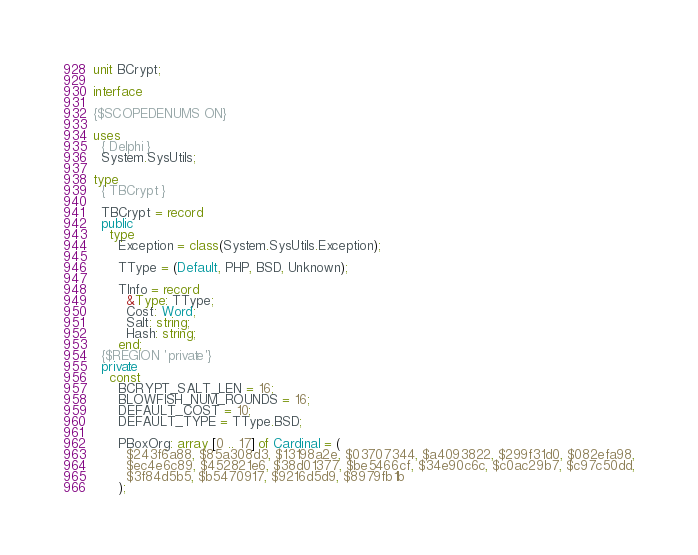<code> <loc_0><loc_0><loc_500><loc_500><_Pascal_>unit BCrypt;

interface

{$SCOPEDENUMS ON}

uses
  { Delphi }
  System.SysUtils;

type
  { TBCrypt }

  TBCrypt = record
  public
    type
      Exception = class(System.SysUtils.Exception);

      TType = (Default, PHP, BSD, Unknown);

      TInfo = record
        &Type: TType;
        Cost: Word;
        Salt: string;
        Hash: string;
      end;
  {$REGION 'private'}
  private
    const
      BCRYPT_SALT_LEN = 16;
      BLOWFISH_NUM_ROUNDS = 16;
      DEFAULT_COST = 10;
      DEFAULT_TYPE = TType.BSD;

      PBoxOrg: array [0 .. 17] of Cardinal = (
        $243f6a88, $85a308d3, $13198a2e, $03707344, $a4093822, $299f31d0, $082efa98,
        $ec4e6c89, $452821e6, $38d01377, $be5466cf, $34e90c6c, $c0ac29b7, $c97c50dd,
        $3f84d5b5, $b5470917, $9216d5d9, $8979fb1b
      );
</code> 